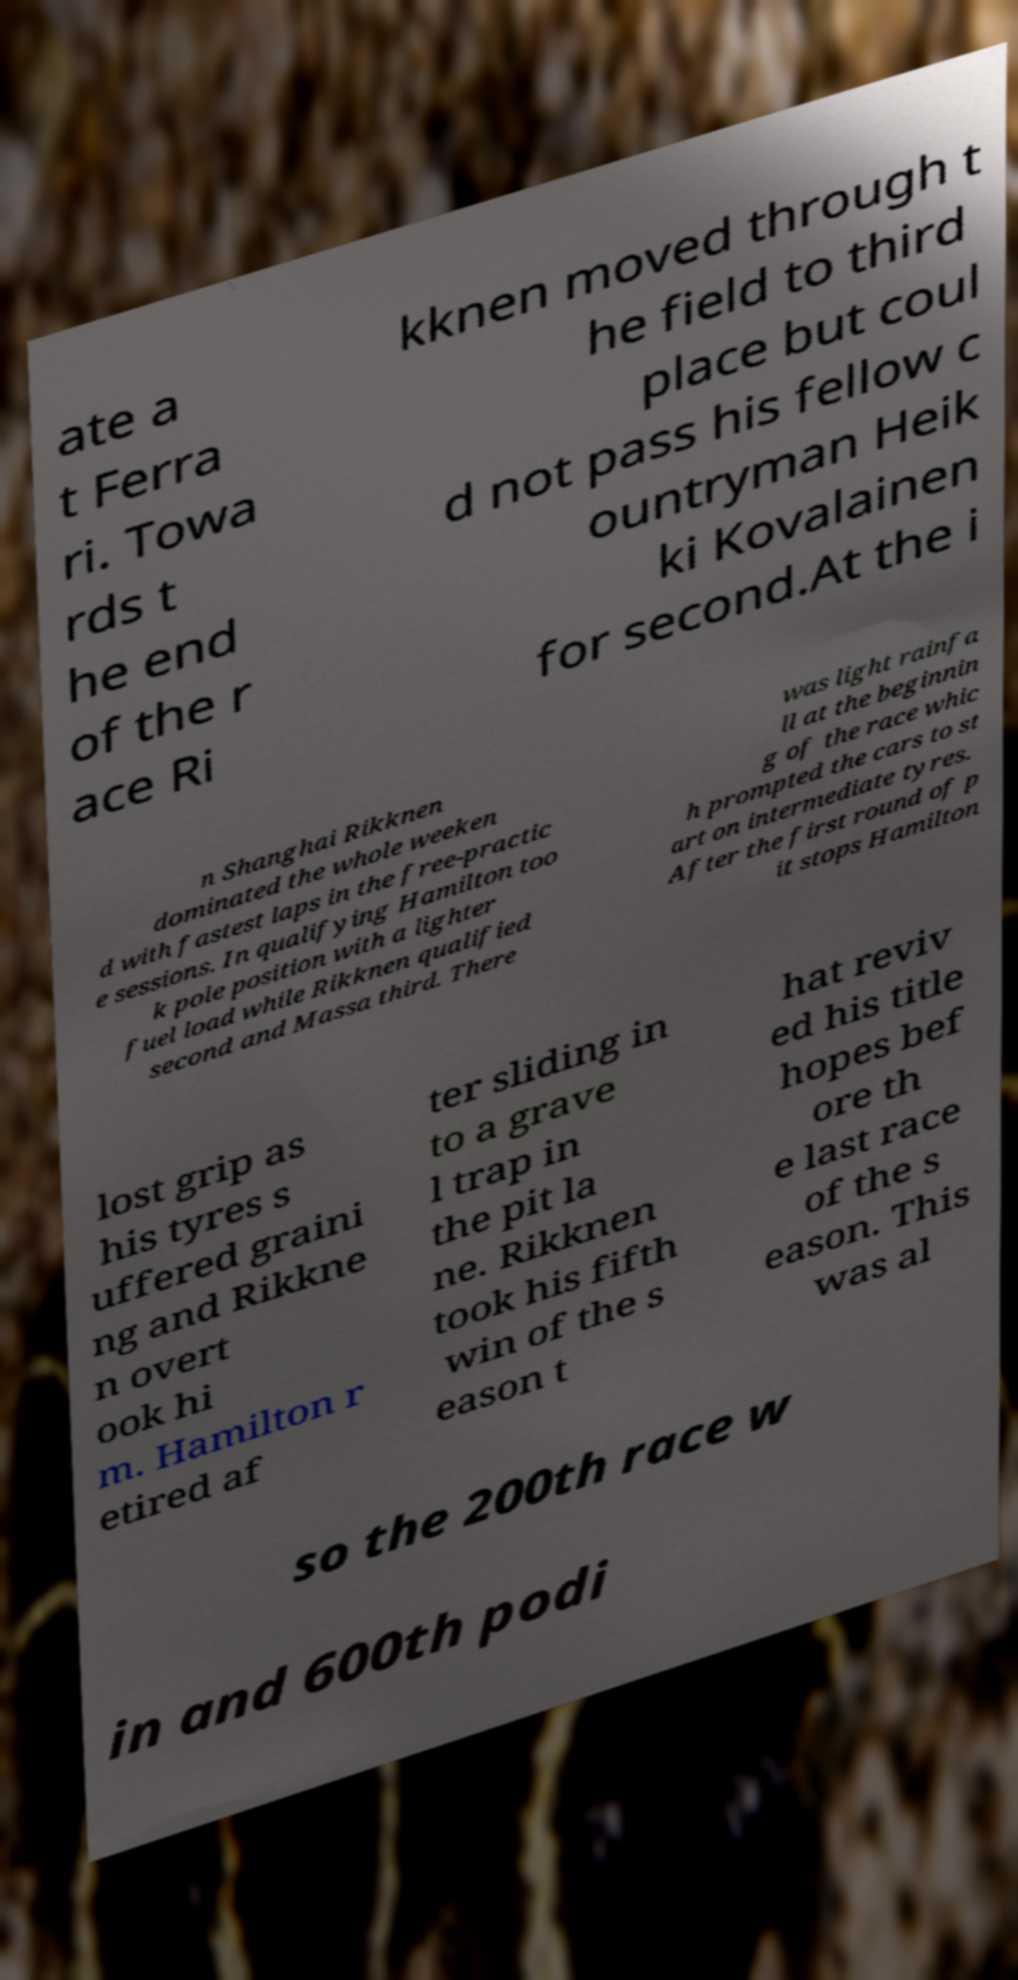What messages or text are displayed in this image? I need them in a readable, typed format. ate a t Ferra ri. Towa rds t he end of the r ace Ri kknen moved through t he field to third place but coul d not pass his fellow c ountryman Heik ki Kovalainen for second.At the i n Shanghai Rikknen dominated the whole weeken d with fastest laps in the free-practic e sessions. In qualifying Hamilton too k pole position with a lighter fuel load while Rikknen qualified second and Massa third. There was light rainfa ll at the beginnin g of the race whic h prompted the cars to st art on intermediate tyres. After the first round of p it stops Hamilton lost grip as his tyres s uffered graini ng and Rikkne n overt ook hi m. Hamilton r etired af ter sliding in to a grave l trap in the pit la ne. Rikknen took his fifth win of the s eason t hat reviv ed his title hopes bef ore th e last race of the s eason. This was al so the 200th race w in and 600th podi 